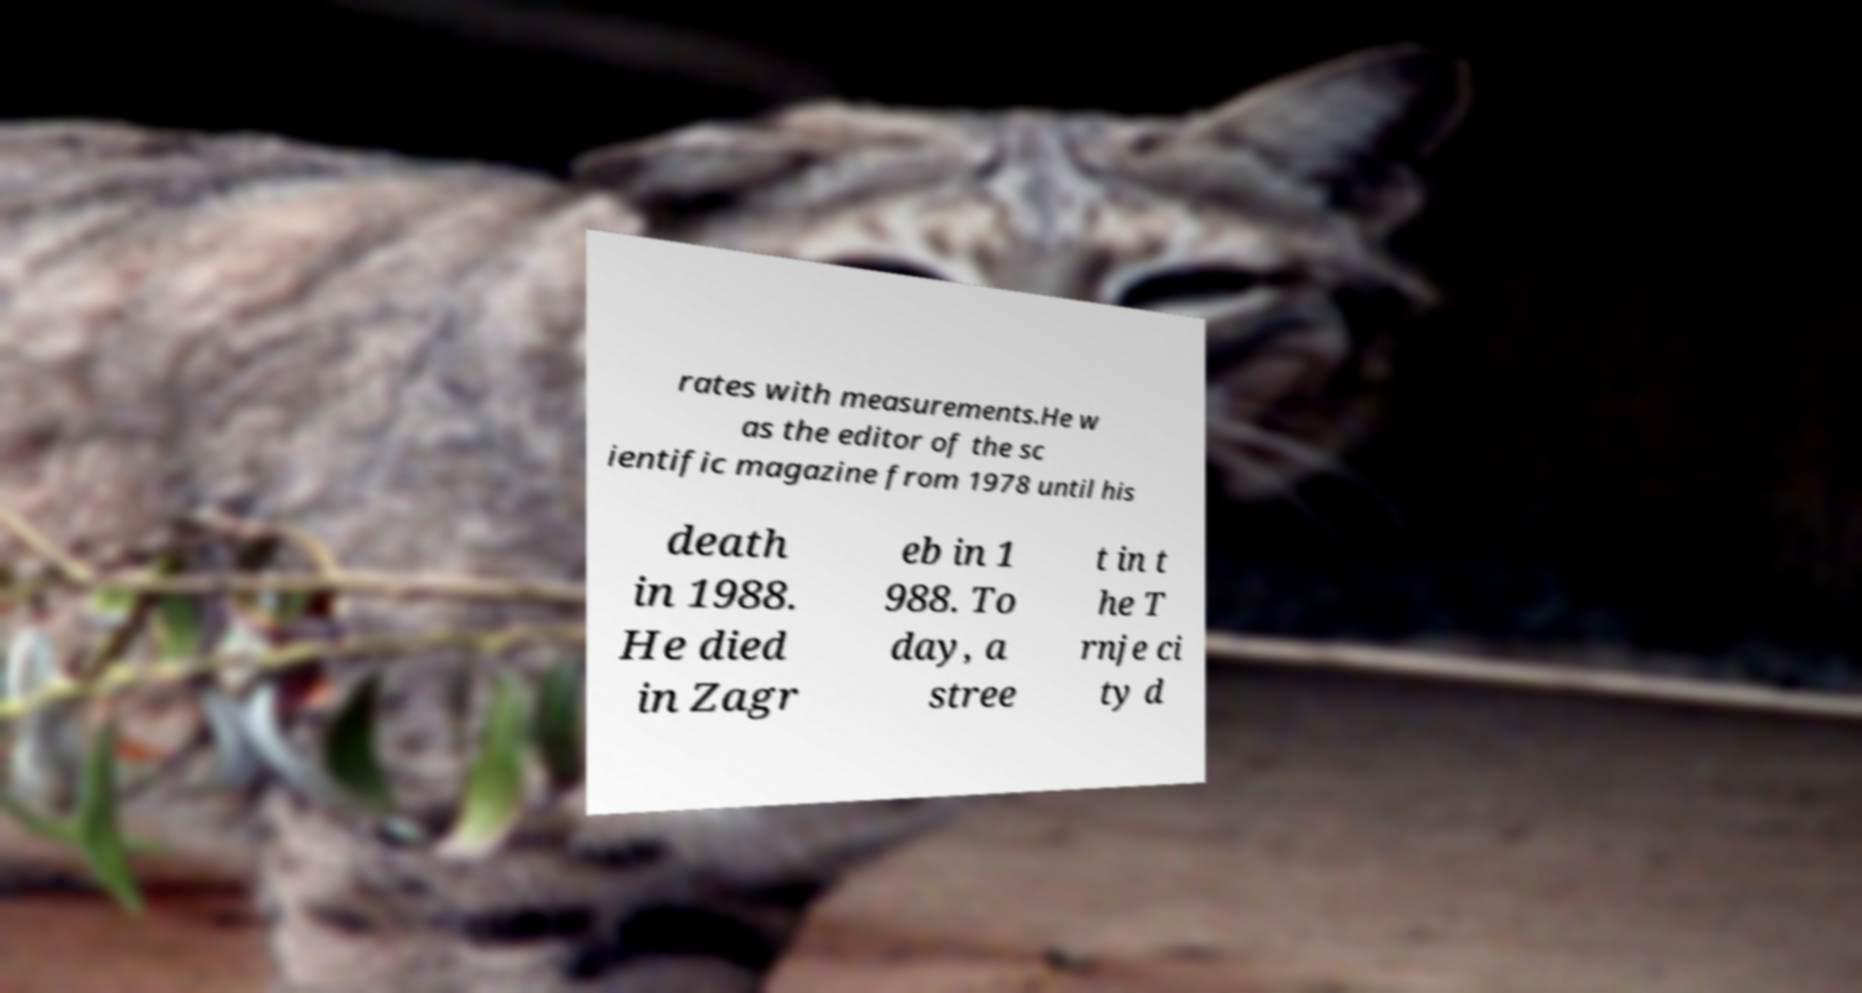Could you assist in decoding the text presented in this image and type it out clearly? rates with measurements.He w as the editor of the sc ientific magazine from 1978 until his death in 1988. He died in Zagr eb in 1 988. To day, a stree t in t he T rnje ci ty d 